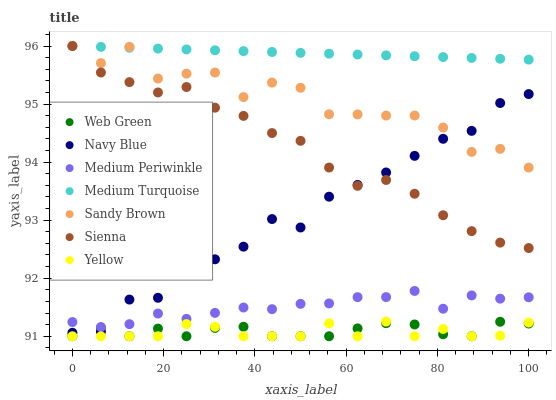Does Yellow have the minimum area under the curve?
Answer yes or no. Yes. Does Medium Turquoise have the maximum area under the curve?
Answer yes or no. Yes. Does Medium Periwinkle have the minimum area under the curve?
Answer yes or no. No. Does Medium Periwinkle have the maximum area under the curve?
Answer yes or no. No. Is Medium Turquoise the smoothest?
Answer yes or no. Yes. Is Sandy Brown the roughest?
Answer yes or no. Yes. Is Medium Periwinkle the smoothest?
Answer yes or no. No. Is Medium Periwinkle the roughest?
Answer yes or no. No. Does Web Green have the lowest value?
Answer yes or no. Yes. Does Medium Periwinkle have the lowest value?
Answer yes or no. No. Does Sandy Brown have the highest value?
Answer yes or no. Yes. Does Medium Periwinkle have the highest value?
Answer yes or no. No. Is Yellow less than Navy Blue?
Answer yes or no. Yes. Is Medium Turquoise greater than Yellow?
Answer yes or no. Yes. Does Web Green intersect Yellow?
Answer yes or no. Yes. Is Web Green less than Yellow?
Answer yes or no. No. Is Web Green greater than Yellow?
Answer yes or no. No. Does Yellow intersect Navy Blue?
Answer yes or no. No. 